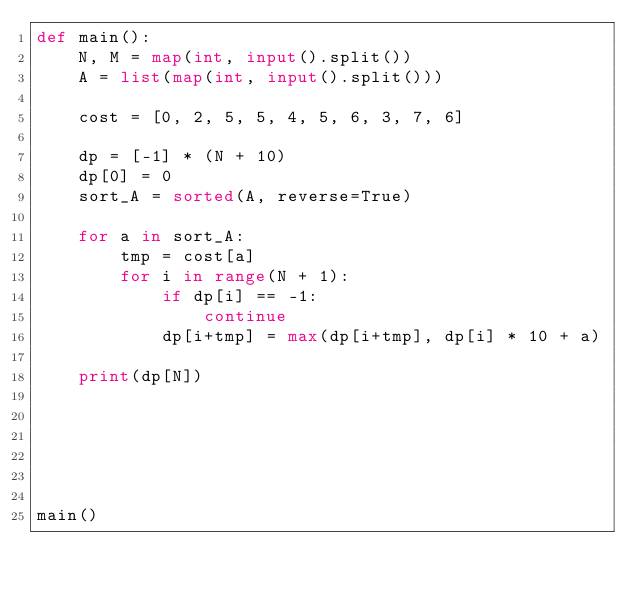<code> <loc_0><loc_0><loc_500><loc_500><_Python_>def main():
    N, M = map(int, input().split())
    A = list(map(int, input().split()))

    cost = [0, 2, 5, 5, 4, 5, 6, 3, 7, 6]

    dp = [-1] * (N + 10)
    dp[0] = 0
    sort_A = sorted(A, reverse=True)

    for a in sort_A:
        tmp = cost[a]
        for i in range(N + 1):
            if dp[i] == -1:
                continue
            dp[i+tmp] = max(dp[i+tmp], dp[i] * 10 + a)

    print(dp[N])






main()</code> 